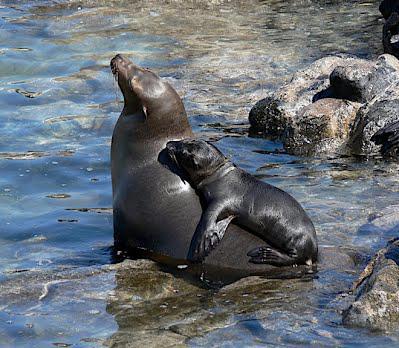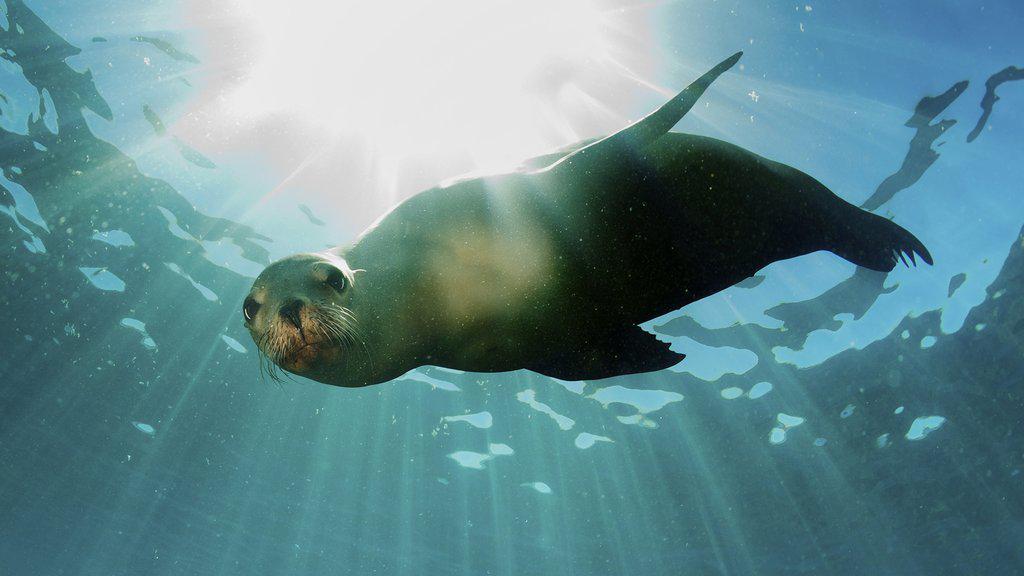The first image is the image on the left, the second image is the image on the right. Given the left and right images, does the statement "One or more seals are sitting on a rock in both images." hold true? Answer yes or no. No. 